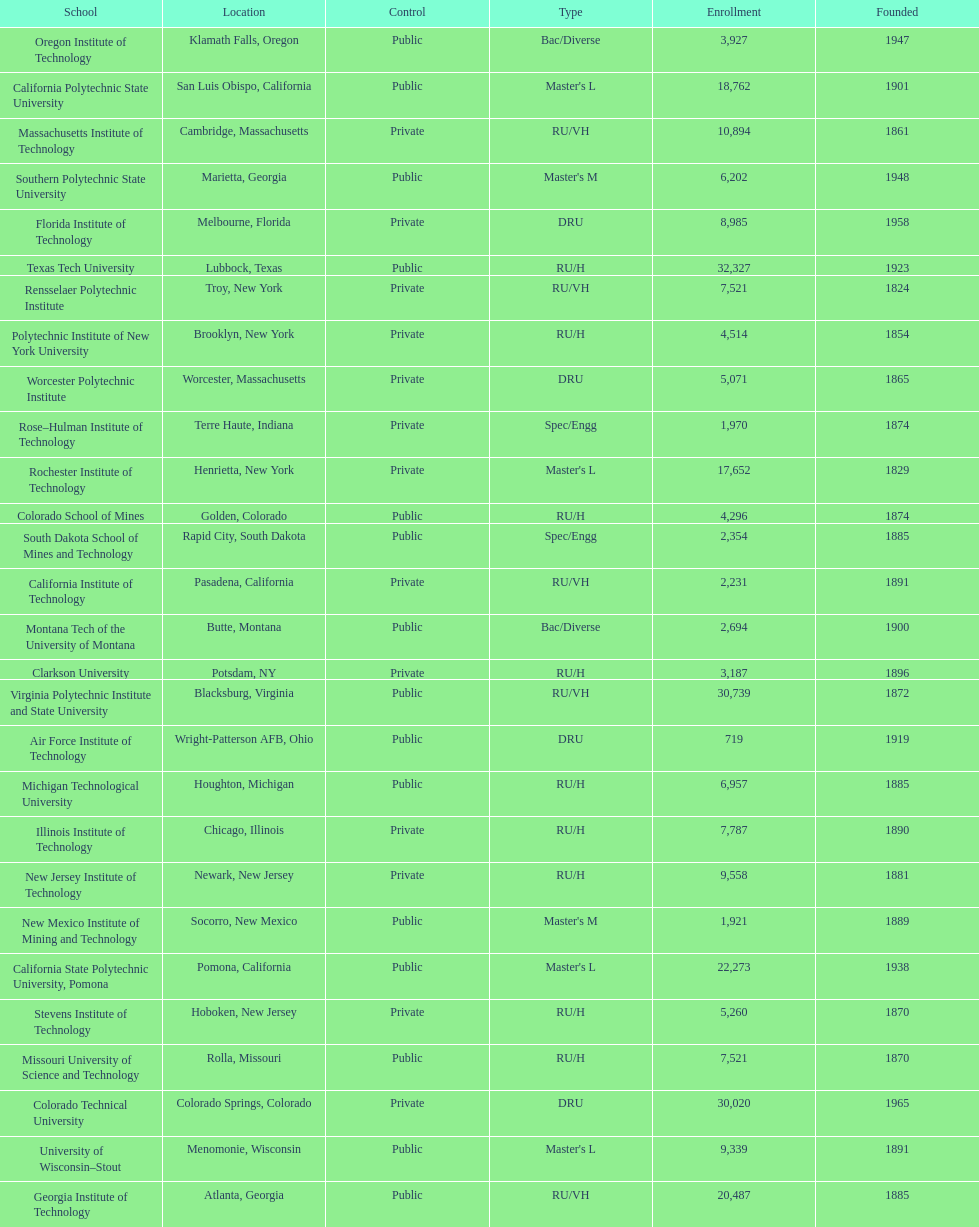Which of the universities was founded first? Rensselaer Polytechnic Institute. 